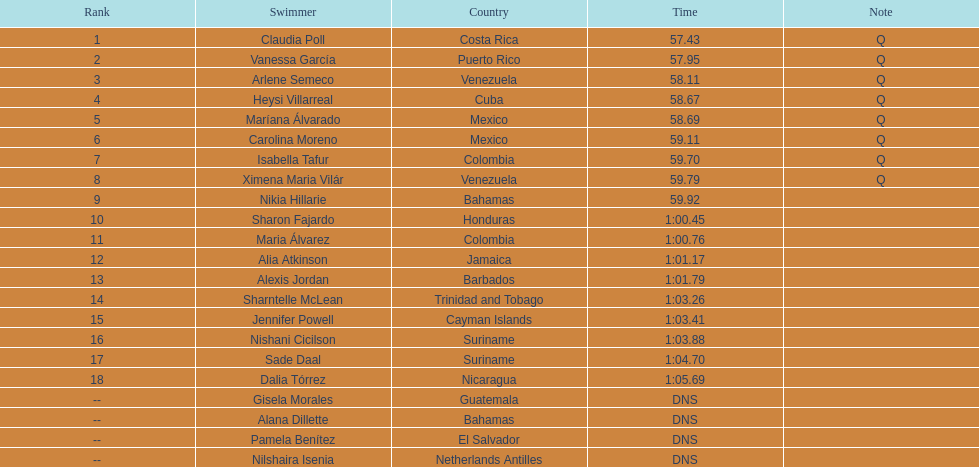Who was the sole cuban to end in the top eight? Heysi Villarreal. 